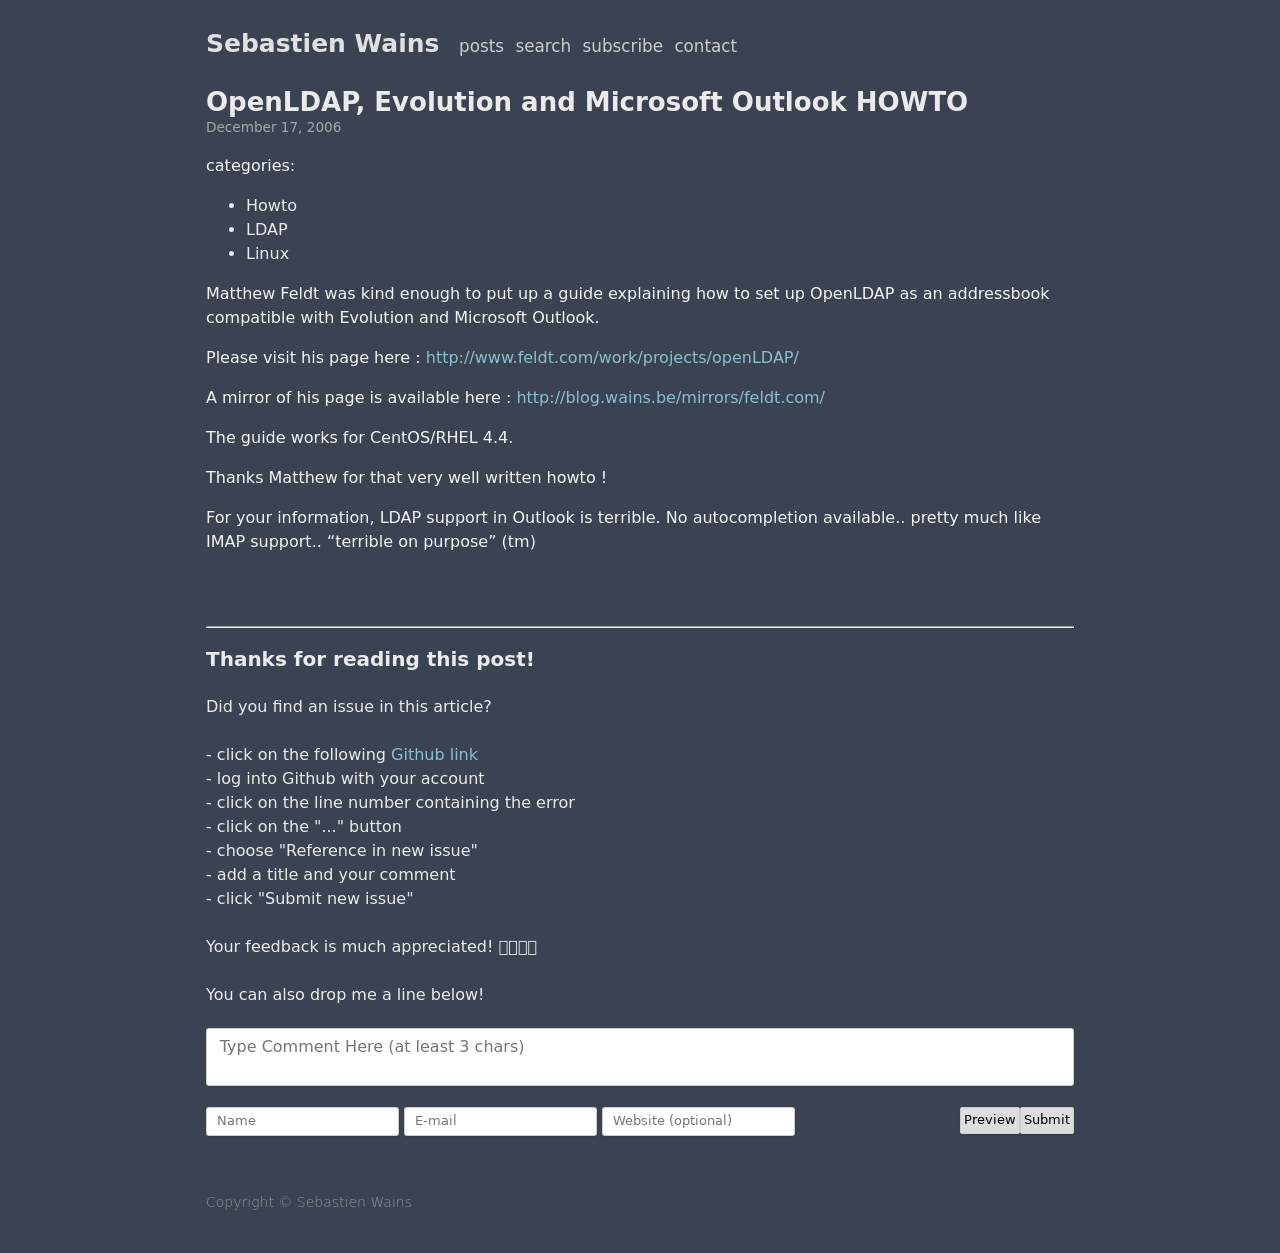What are some follow-up steps I can take after setting up the basic HTML structure to enhance my website? After setting up the basic HTML structure, you can enhance your website by: adding CSS for styling, incorporating JavaScript for interactive elements, using media queries for responsive design, and integrating multimedia like images and videos. Each of these components will help improve the user experience and aesthetic of your site. 